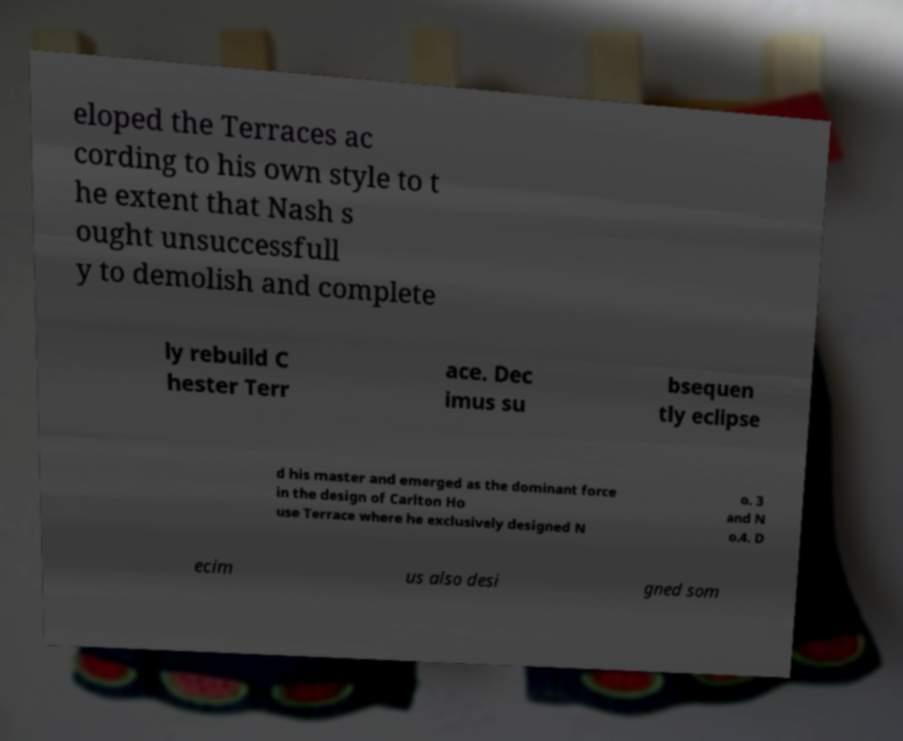There's text embedded in this image that I need extracted. Can you transcribe it verbatim? eloped the Terraces ac cording to his own style to t he extent that Nash s ought unsuccessfull y to demolish and complete ly rebuild C hester Terr ace. Dec imus su bsequen tly eclipse d his master and emerged as the dominant force in the design of Carlton Ho use Terrace where he exclusively designed N o. 3 and N o.4. D ecim us also desi gned som 